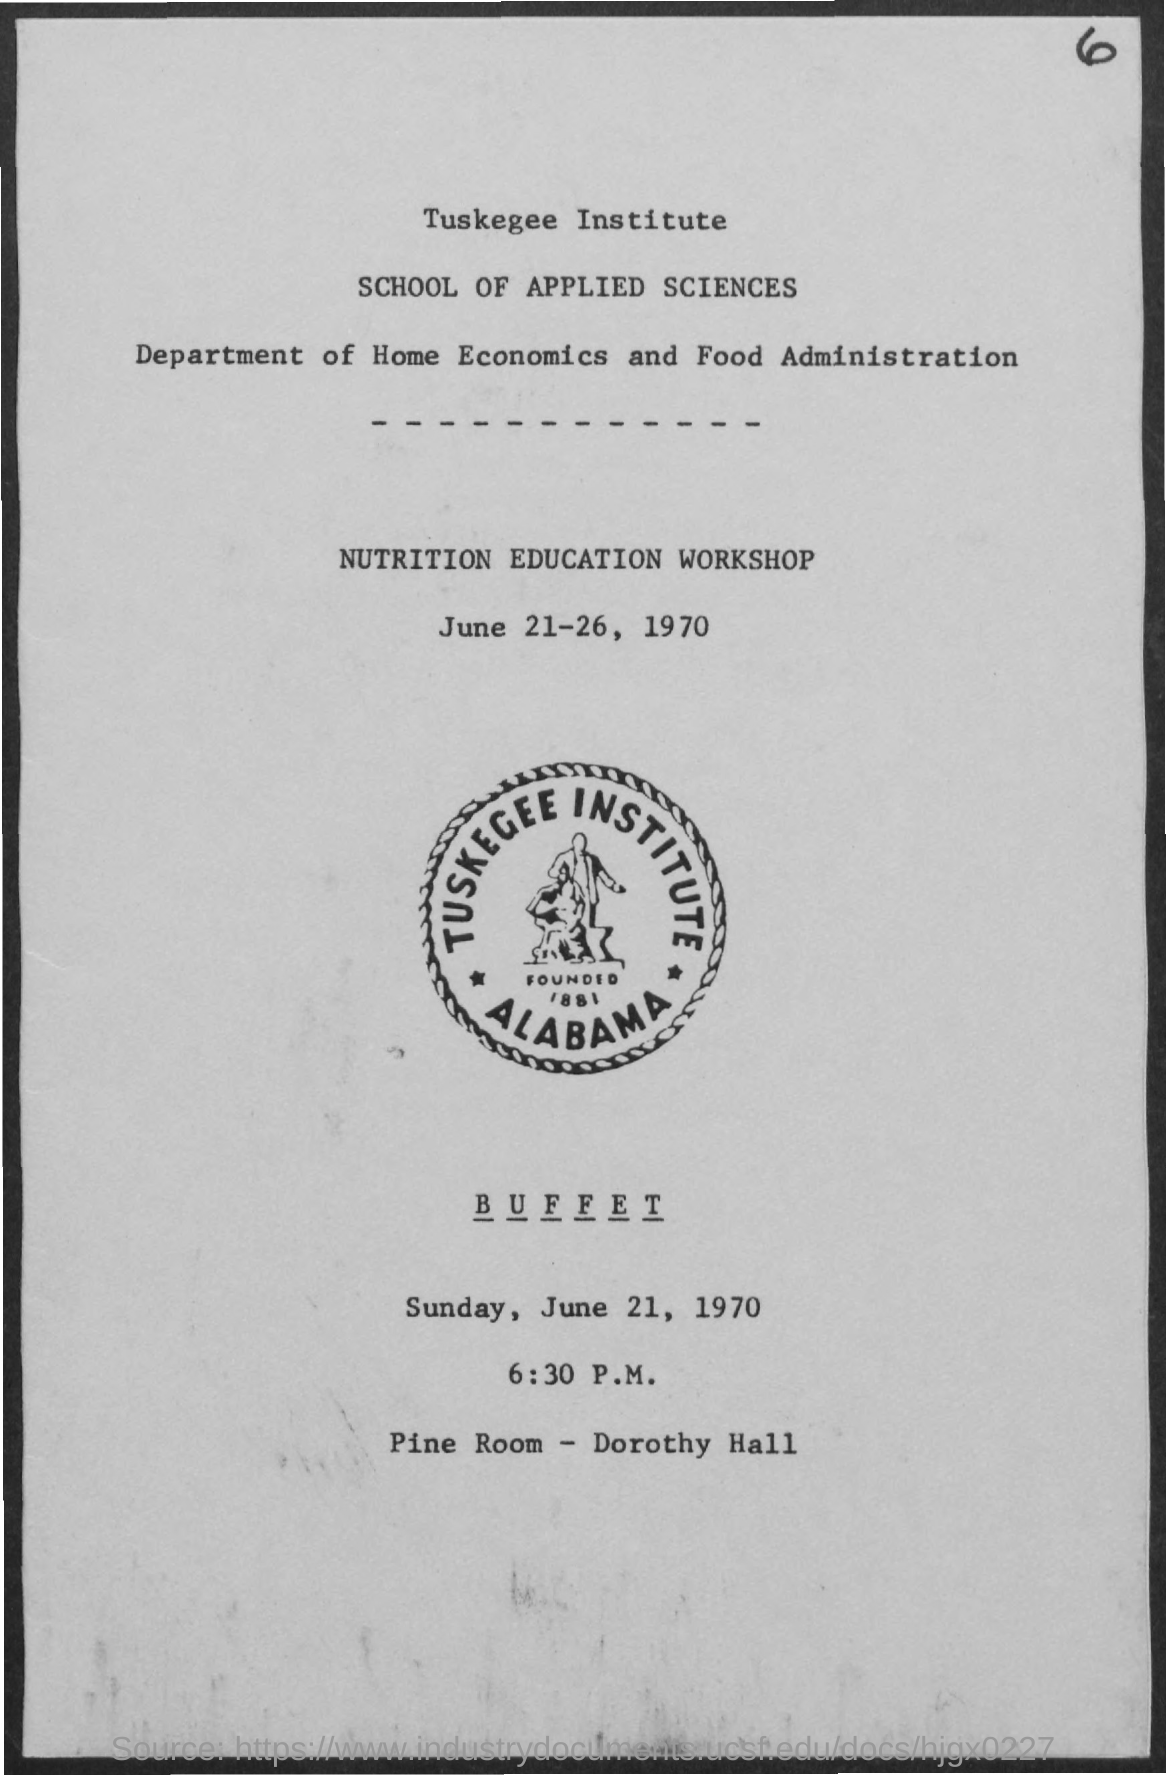When is the Nutrition Education Workshop?
Your response must be concise. June 21-26, 1970. When is the Buffet?
Offer a terse response. Sunday, june 21, 1970. What is the Location of the Buffet?
Provide a succinct answer. Pine Room - Dorothy Hall. 